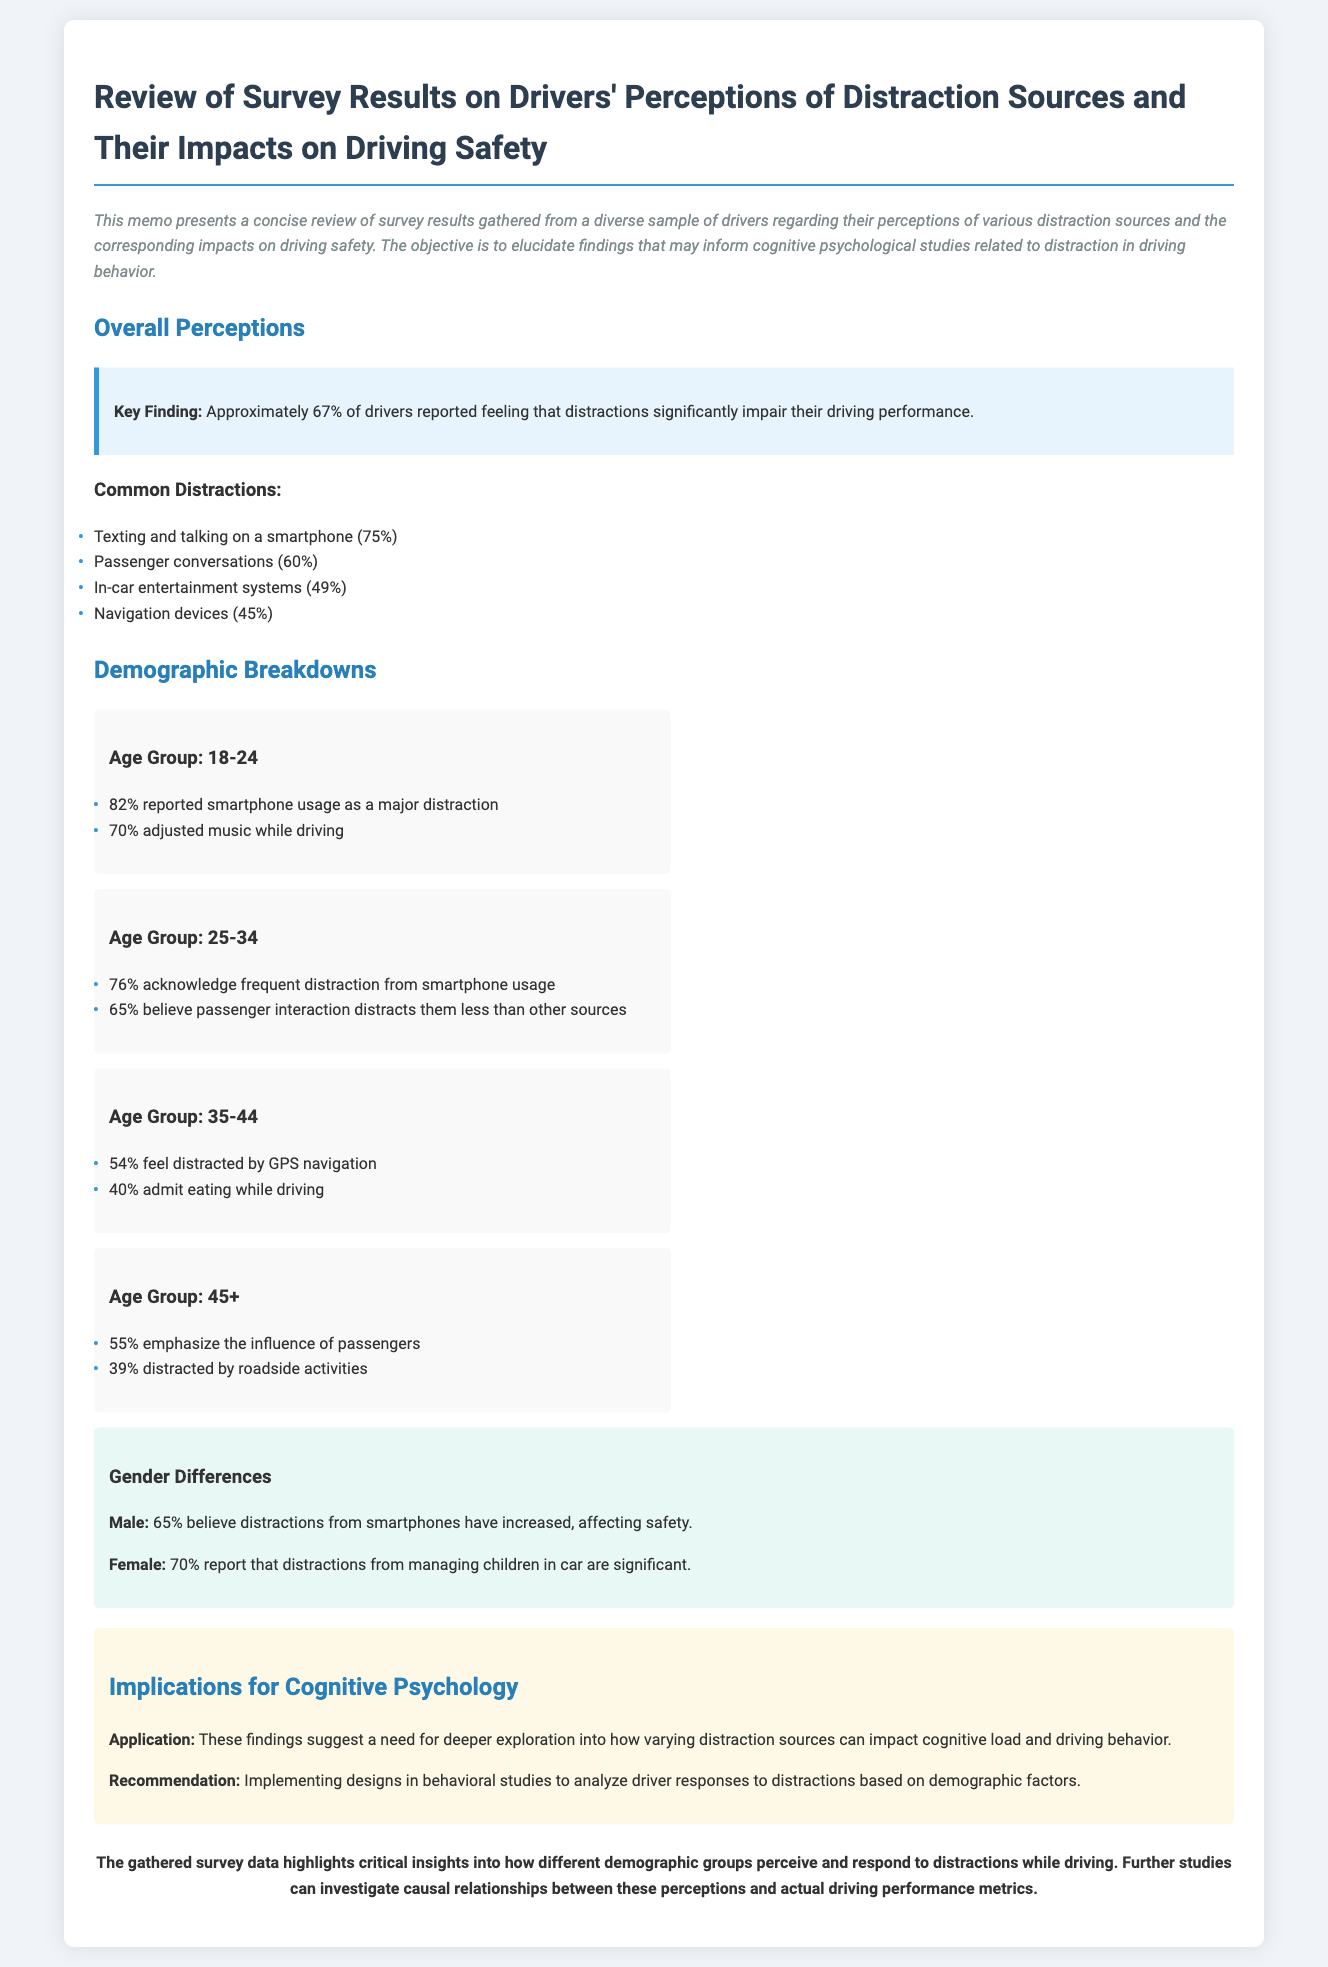What percentage of drivers feel distractions impair their performance? Approximately 67% of drivers reported feeling that distractions significantly impair their driving performance.
Answer: 67% What did 75% of drivers identify as a major distraction? 75% of drivers reported texting and talking on a smartphone as a major distraction.
Answer: Texting and talking on a smartphone Which age group reported the highest percentage of smartphone usage as a major distraction? The age group 18-24 reported 82% smartphone usage as a major distraction, which is the highest among the groups.
Answer: 18-24 What implication is suggested for cognitive psychology? The implication suggests a need for deeper exploration into how varying distraction sources can impact cognitive load and driving behavior.
Answer: Deeper exploration into distraction sources What percentage of male drivers believe smartphone distractions have increased? 65% of male drivers believe distractions from smartphones have increased, affecting safety.
Answer: 65% How many drivers in the age group 35-44 admit to eating while driving? 40% of drivers in the age group 35-44 admit eating while driving.
Answer: 40% What recommendation is provided regarding behavioral studies? The recommendation is to implement designs in behavioral studies to analyze driver responses to distractions based on demographic factors.
Answer: Analyze driver responses by demographics Which group emphasizes the influence of passengers as a distraction? The age group 45+ emphasizes the influence of passengers as a significant distraction, with 55% reporting this.
Answer: Age group 45+ 